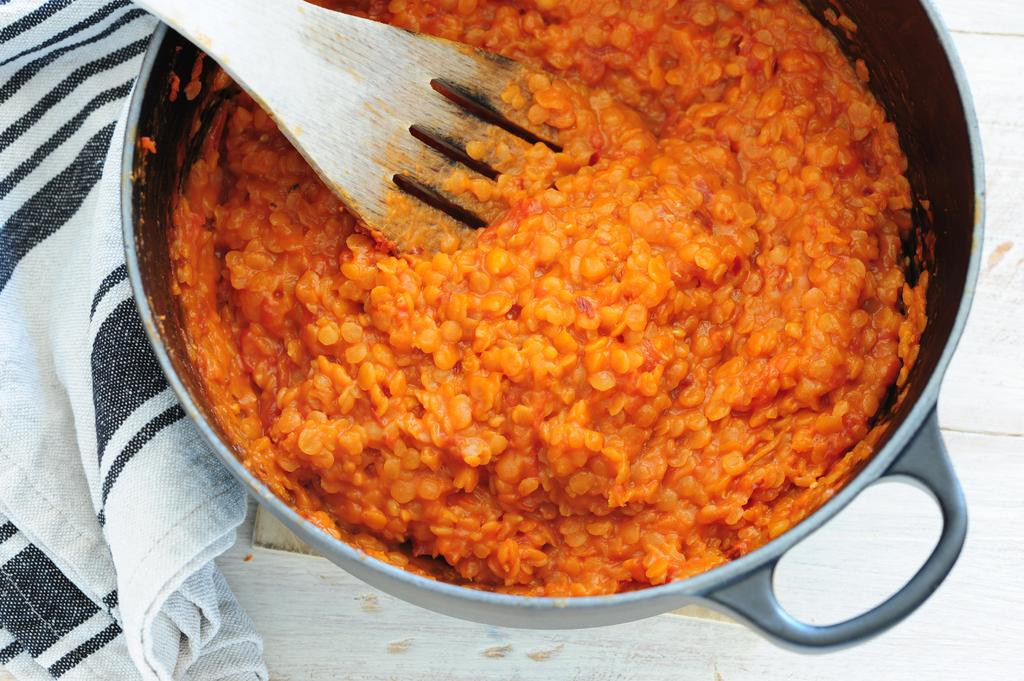What material is present in the image? There is cloth in the image. What cooking utensil can be seen in the image? There is a wooden spoon in the image. What is the wooden spoon used with in the image? The wooden spoon is used with a fry pan with food in the image. Where are the fry pan and wooden spoon located in the image? The fry pan and wooden spoon are on a platform in the image. How does the love between the two characters in the image manifest itself? There are no characters or any indication of love in the image; it features a fry pan, wooden spoon, cloth, and a platform. Can you describe the recess in the image where the characters are having a conversation? There is no recess or any characters present in the image. 